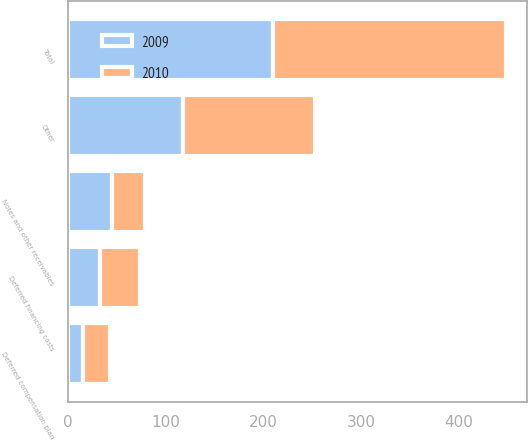Convert chart. <chart><loc_0><loc_0><loc_500><loc_500><stacked_bar_chart><ecel><fcel>Deferred financing costs<fcel>Deferred compensation plan<fcel>Notes and other receivables<fcel>Other<fcel>Total<nl><fcel>2010<fcel>41.1<fcel>27.4<fcel>34<fcel>135.4<fcel>237.9<nl><fcel>2009<fcel>32.4<fcel>15.2<fcel>45.1<fcel>117.4<fcel>210.1<nl></chart> 